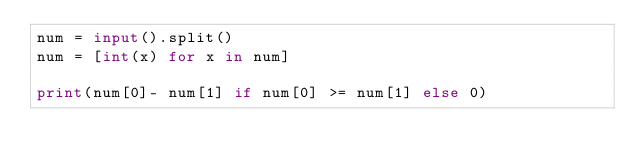Convert code to text. <code><loc_0><loc_0><loc_500><loc_500><_Python_>num = input().split()
num = [int(x) for x in num]

print(num[0]- num[1] if num[0] >= num[1] else 0)</code> 